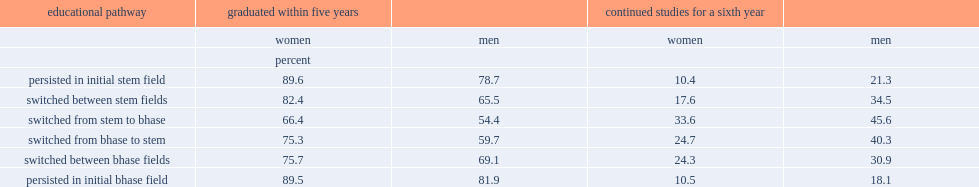How many percentage points did women graduate within five years among those who persisted in their initial stem field of study? 89.6. How many percentage points did men graduate within five years among those who persisted in their initial stem field of study? 78.7. 